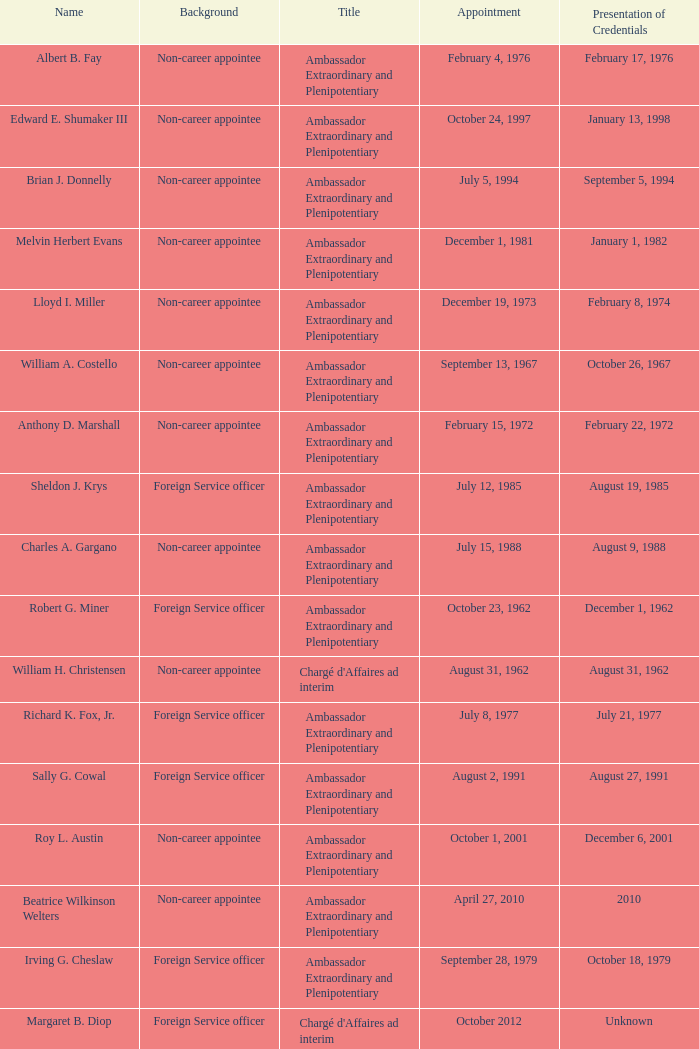Who presented their credentials at an unknown date? Margaret B. Diop. 